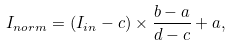<formula> <loc_0><loc_0><loc_500><loc_500>I _ { n o r m } = ( I _ { i n } - c ) \times \frac { b - a } { d - c } + a ,</formula> 